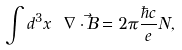Convert formula to latex. <formula><loc_0><loc_0><loc_500><loc_500>\int d ^ { 3 } x \ \nabla \cdot \vec { B } = 2 \pi \frac { \hbar { c } } { e } N ,</formula> 